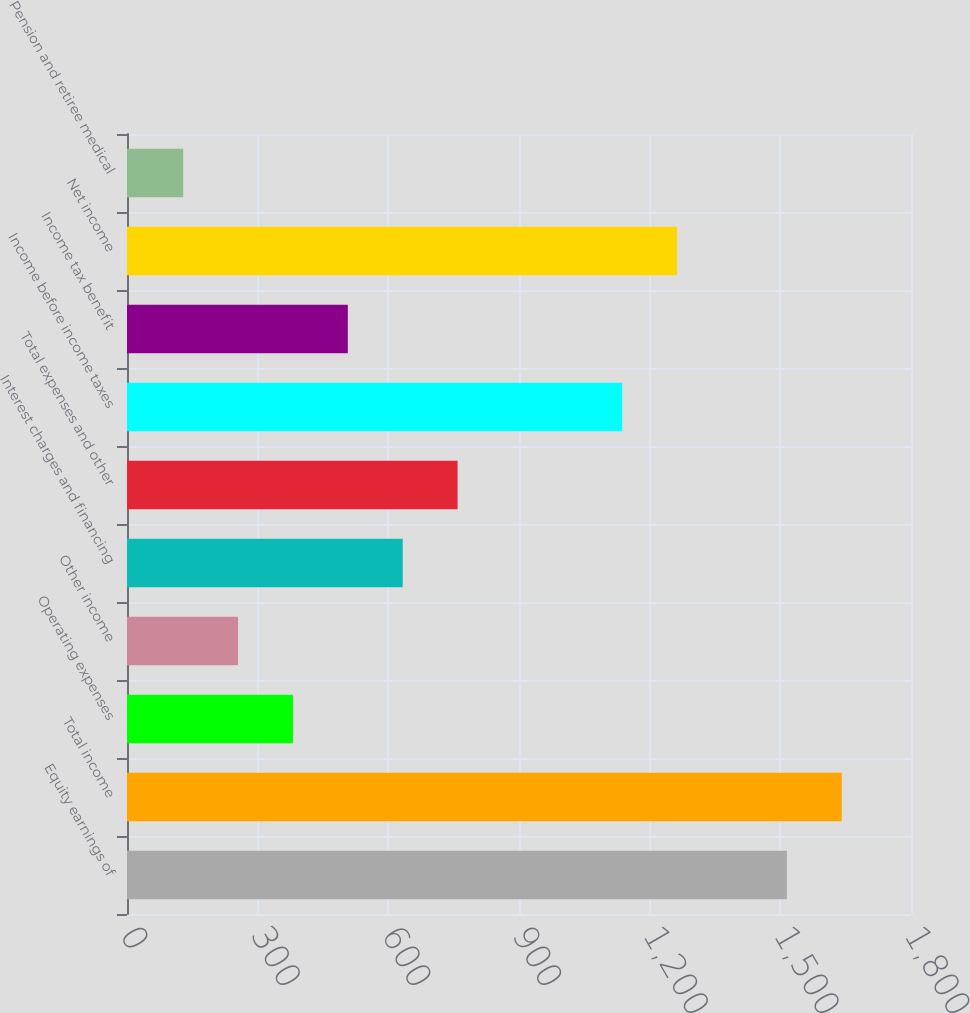Convert chart. <chart><loc_0><loc_0><loc_500><loc_500><bar_chart><fcel>Equity earnings of<fcel>Total income<fcel>Operating expenses<fcel>Other income<fcel>Interest charges and financing<fcel>Total expenses and other<fcel>Income before income taxes<fcel>Income tax benefit<fcel>Net income<fcel>Pension and retiree medical<nl><fcel>1515<fcel>1641<fcel>381<fcel>255<fcel>633<fcel>759<fcel>1137<fcel>507<fcel>1263<fcel>129<nl></chart> 